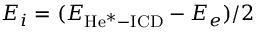Convert formula to latex. <formula><loc_0><loc_0><loc_500><loc_500>E _ { i } = ( E _ { H e ^ { * } - I C D } - E _ { e } ) / 2</formula> 